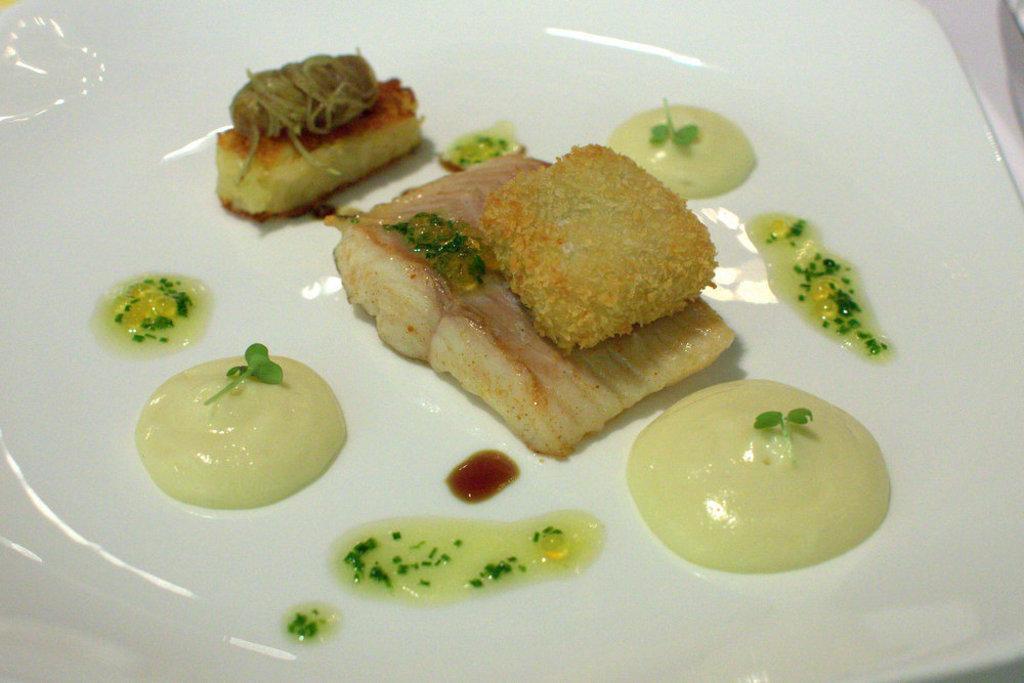In one or two sentences, can you explain what this image depicts? In this image we can see there is the plate and there are some food items in the plate. And at the side, it looks like a cloth. 